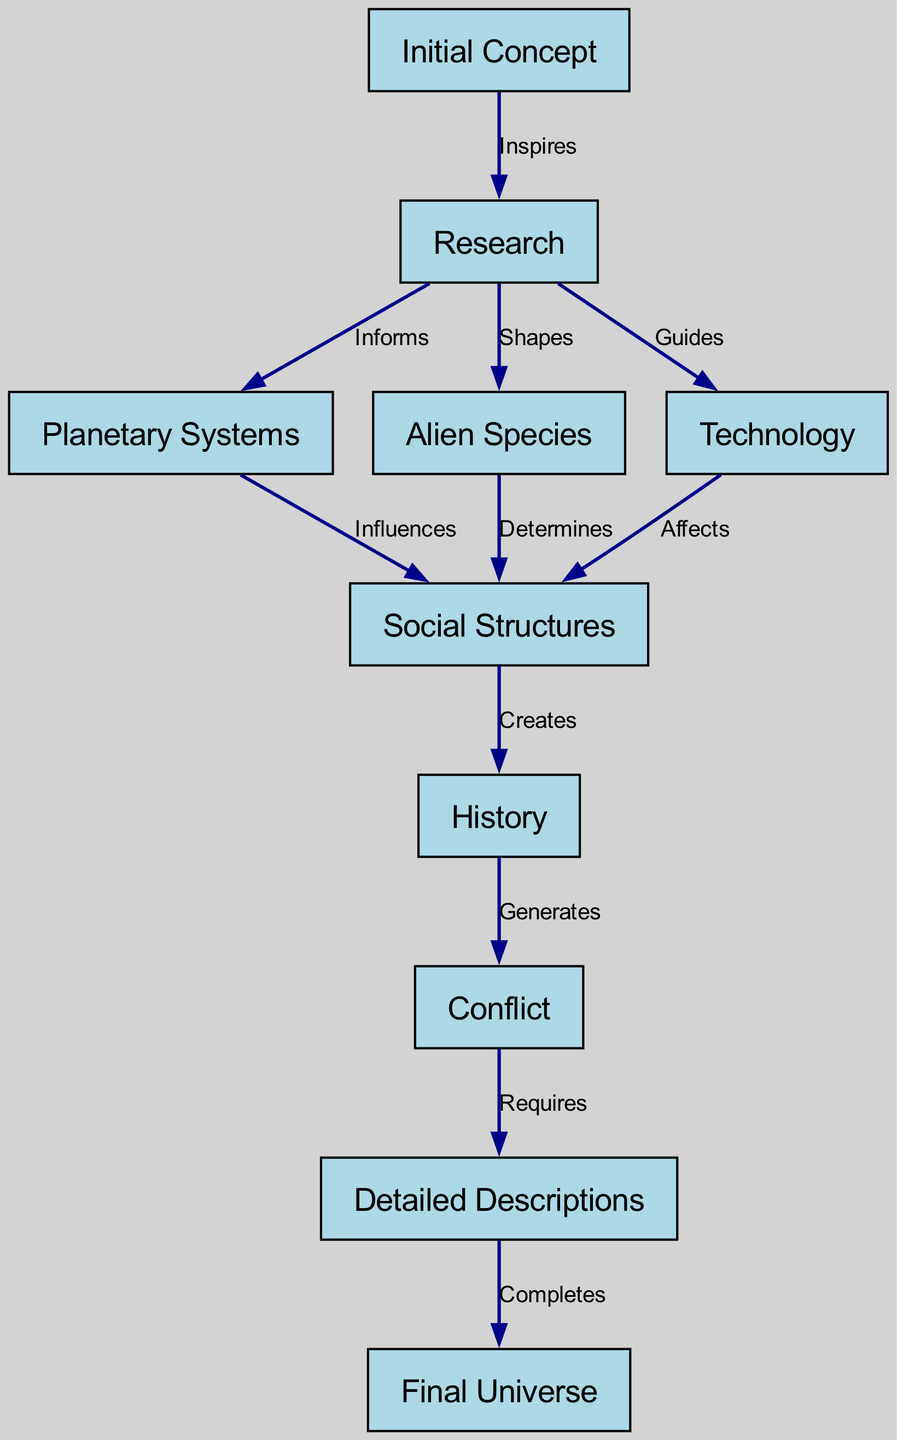What is the initial step in the world-building process? The initial step is "Initial Concept" which represents the starting point of the world-building process before any research or details.
Answer: Initial Concept How many nodes are present in the diagram? Counting each unique concept, we find that there are ten nodes: Initial Concept, Research, Planetary Systems, Alien Species, Technology, Social Structures, History, Conflict, Detailed Descriptions, and Final Universe.
Answer: 10 What relationship does "Research" have with "Alien Species"? The relationship is defined as "Shapes," indicating how research contributes to the design and understanding of the alien species within the universe.
Answer: Shapes Which node comes directly after "Conflict"? The node that follows "Conflict" in the flow of the diagram is "Detailed Descriptions," indicating that conflict necessitates detailed explorations of the universe.
Answer: Detailed Descriptions How many edges connect "Research" to other nodes? Specifically, "Research" connects to three nodes: "Planetary Systems," "Alien Species," and "Technology," resulting in a total of three edges stemming from this node.
Answer: 3 What is created by "Social Structures"? The "Social Structures" node generates "History," implying that the societal framework leads to historical events and narratives in the world-building process.
Answer: History Which node does "History" generate conflict towards? "History" generates "Conflict," showing a direct causal relationship where historical events contribute to the emergence of conflicts within the sci-fi universe.
Answer: Conflict What type of descriptions does "Conflict" require? "Conflict" requires "Detailed Descriptions," suggesting that understanding and depicting conflicts in depth is essential to the overall universe construction.
Answer: Detailed Descriptions Which element influences "Social Structures"? "Planetary Systems" influences "Social Structures," meaning the environmental and physical context of the worlds plays a significant role in shaping societal arrangements.
Answer: Planetary Systems What is the end product of the world-building process? The final node, "Final Universe," represents the culmination of all prior steps and details in the world-building process, encapsulating the entire sci-fi universe created.
Answer: Final Universe 